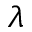<formula> <loc_0><loc_0><loc_500><loc_500>\lambda</formula> 